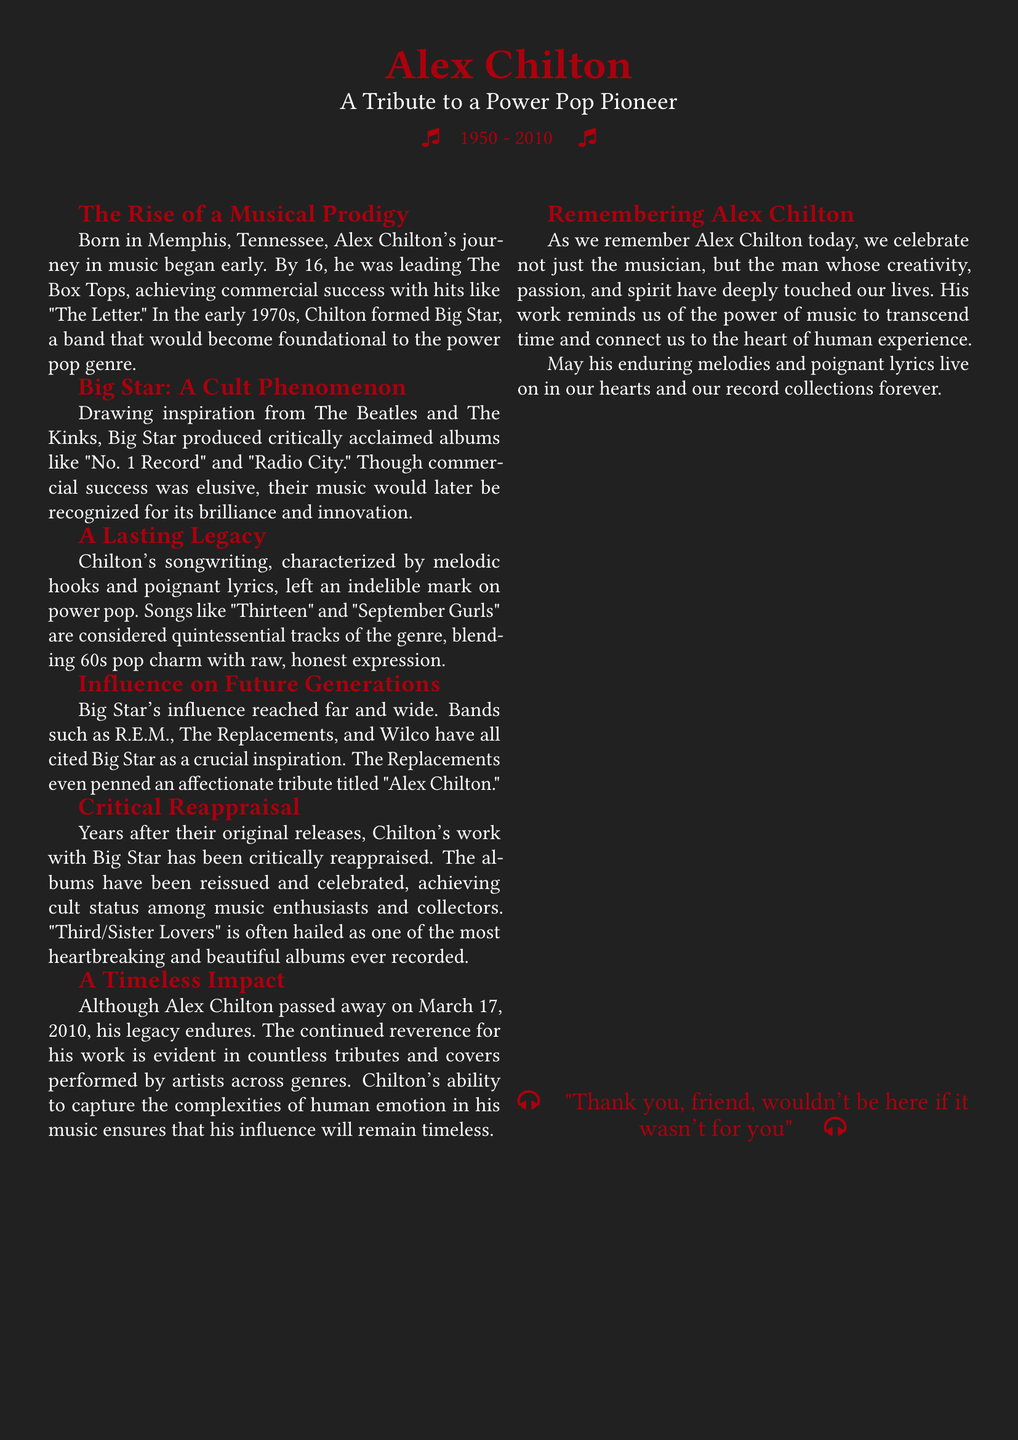What year was Alex Chilton born? The document states that Alex Chilton was born in 1950.
Answer: 1950 What band did Alex Chilton lead at the age of 16? The document mentions that he was leading The Box Tops by 16.
Answer: The Box Tops What is the title of Big Star's critically acclaimed album mentioned in the document? The document lists "No. 1 Record" as one of their albums.
Answer: No. 1 Record Which song is described as a quintessential track of the power pop genre? The document specifically mentions "Thirteen" as one of those tracks.
Answer: Thirteen Which band wrote a tribute song titled "Alex Chilton"? The document states that The Replacements wrote this tribute.
Answer: The Replacements What date did Alex Chilton pass away? The document indicates that he passed away on March 17, 2010.
Answer: March 17, 2010 How did Chilton's work with Big Star eventually change over time? The document notes that Chilton's work has been critically reappraised over the years.
Answer: Critically reappraised What does the document suggest about Chilton's influence on music? It indicates that his influence continues to be evident in tributes and covers across genres.
Answer: Continues to be evident What is the title of one of the most beautiful albums recorded, according to the document? The document refers to "Third/Sister Lovers" as an album that fits this description.
Answer: Third/Sister Lovers 